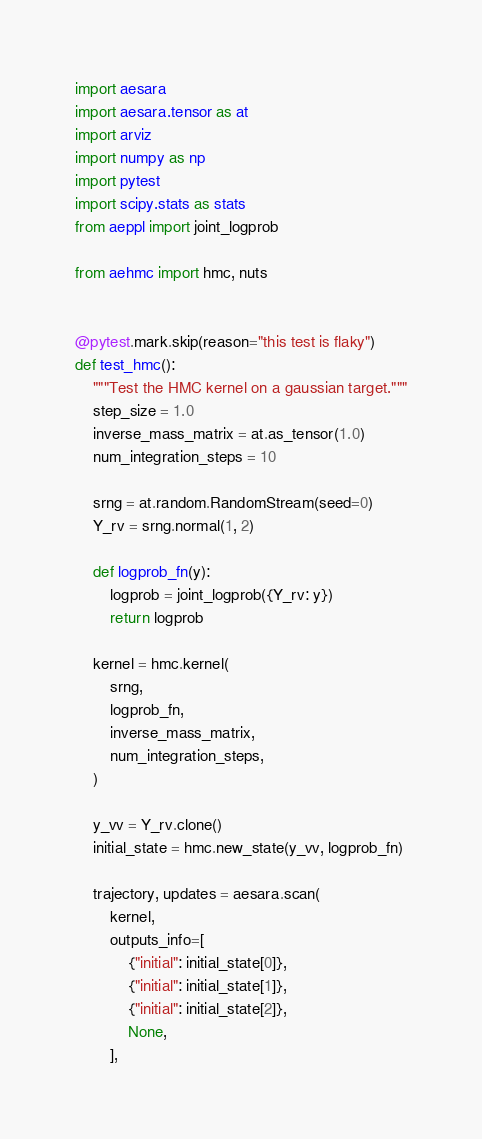Convert code to text. <code><loc_0><loc_0><loc_500><loc_500><_Python_>import aesara
import aesara.tensor as at
import arviz
import numpy as np
import pytest
import scipy.stats as stats
from aeppl import joint_logprob

from aehmc import hmc, nuts


@pytest.mark.skip(reason="this test is flaky")
def test_hmc():
    """Test the HMC kernel on a gaussian target."""
    step_size = 1.0
    inverse_mass_matrix = at.as_tensor(1.0)
    num_integration_steps = 10

    srng = at.random.RandomStream(seed=0)
    Y_rv = srng.normal(1, 2)

    def logprob_fn(y):
        logprob = joint_logprob({Y_rv: y})
        return logprob

    kernel = hmc.kernel(
        srng,
        logprob_fn,
        inverse_mass_matrix,
        num_integration_steps,
    )

    y_vv = Y_rv.clone()
    initial_state = hmc.new_state(y_vv, logprob_fn)

    trajectory, updates = aesara.scan(
        kernel,
        outputs_info=[
            {"initial": initial_state[0]},
            {"initial": initial_state[1]},
            {"initial": initial_state[2]},
            None,
        ],</code> 